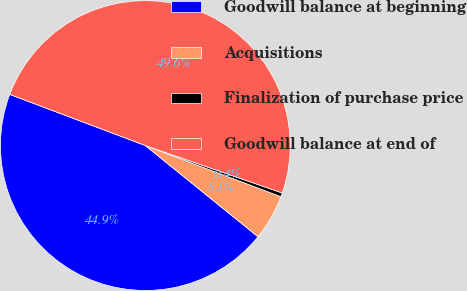Convert chart to OTSL. <chart><loc_0><loc_0><loc_500><loc_500><pie_chart><fcel>Goodwill balance at beginning<fcel>Acquisitions<fcel>Finalization of purchase price<fcel>Goodwill balance at end of<nl><fcel>44.91%<fcel>5.09%<fcel>0.43%<fcel>49.57%<nl></chart> 